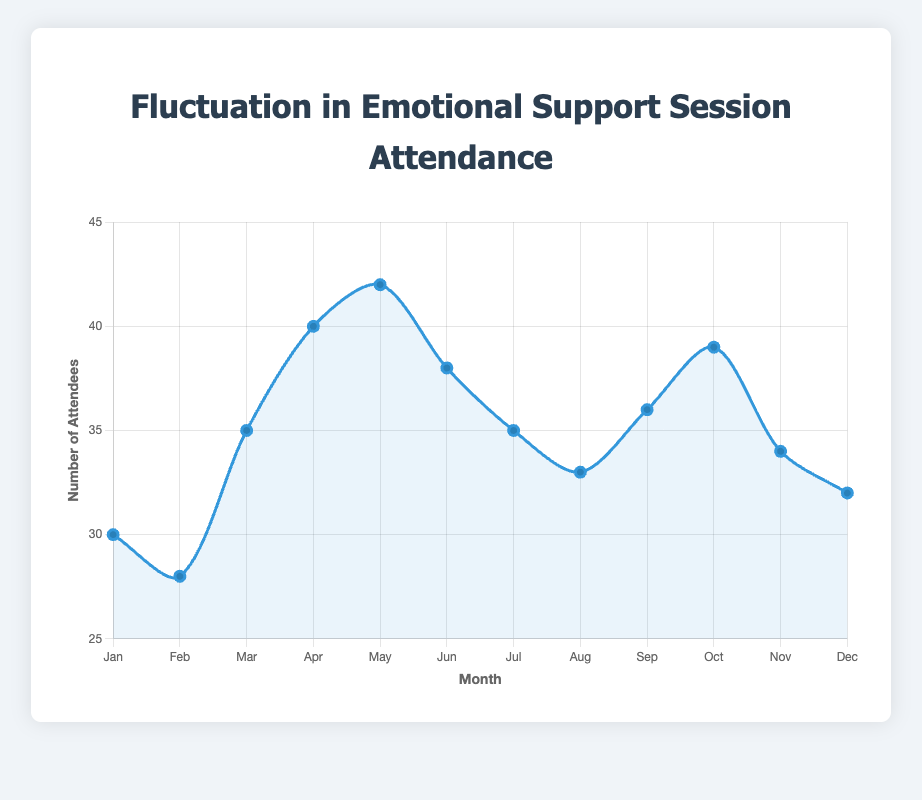What's the month with the highest attendance? The highest point on the line chart represents the highest attendance. Looking at the visual information, the highest attendance is in May with 42 attendees.
Answer: May What's the difference in attendance between April and February? To find the difference, we subtract the attendance in February from the attendance in April. From the chart, April has 40 attendees and February has 28 attendees. So, 40 - 28 = 12.
Answer: 12 During which season does the attendance peak? By visually inspecting the seasonal trend on the line chart, we see that the highest data point occurs in May, which is in Spring. Hence, the attendance peaks in Spring.
Answer: Spring What is the average attendance in the Fall season? To find the average attendance in Fall, add up the attendance for September, October, and November, then divide by the number of months (3). So, (36 + 39 + 34) / 3 = 109 / 3 = 36.33.
Answer: 36.33 How does the attendance in January compare to that in March? Comparing the two data points directly from the chart, January has 30 attendees and March has 35 attendees. March has 5 more attendees than January.
Answer: March has 5 more attendees Is the attendance generally higher in Winter or Summer? To compare, we sum the attendance for Winter and Summer months. Winter: 30 + 28 + 32 = 90. Summer: 38 + 35 + 33 = 106. Summer has higher attendance (106) compared to Winter (90).
Answer: Summer Which month shows the lowest attendance? The lowest point on the line chart indicates the lowest attendance. According to the visual information, the lowest attendance is in February with 28 attendees.
Answer: February Calculate the total attendance for the Spring season. Add up the attendance for March, April, and May. So, 35 + 40 + 42 = 117.
Answer: 117 How much higher is the attendance in May compared to July? To find the difference, subtract the attendance in July from May. So, 42 - 35 = 7.
Answer: 7 What's the median attendance over the entire year? To find the median, list all attendance numbers in ascending order: [28, 30, 32, 33, 34, 35, 35, 36, 38, 39, 40, 42]. The middle values are the 6th and 7th numbers: 35 and 35. Thus, the median attendance is (35 + 35) / 2 = 35.
Answer: 35 